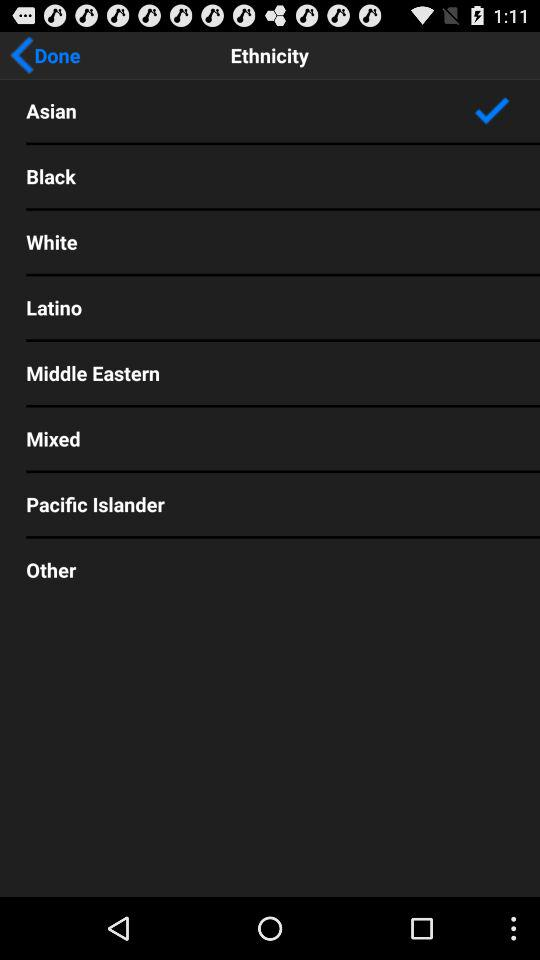How many ethnicities are there?
Answer the question using a single word or phrase. 8 